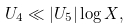<formula> <loc_0><loc_0><loc_500><loc_500>U _ { 4 } \ll | U _ { 5 } | \log X ,</formula> 